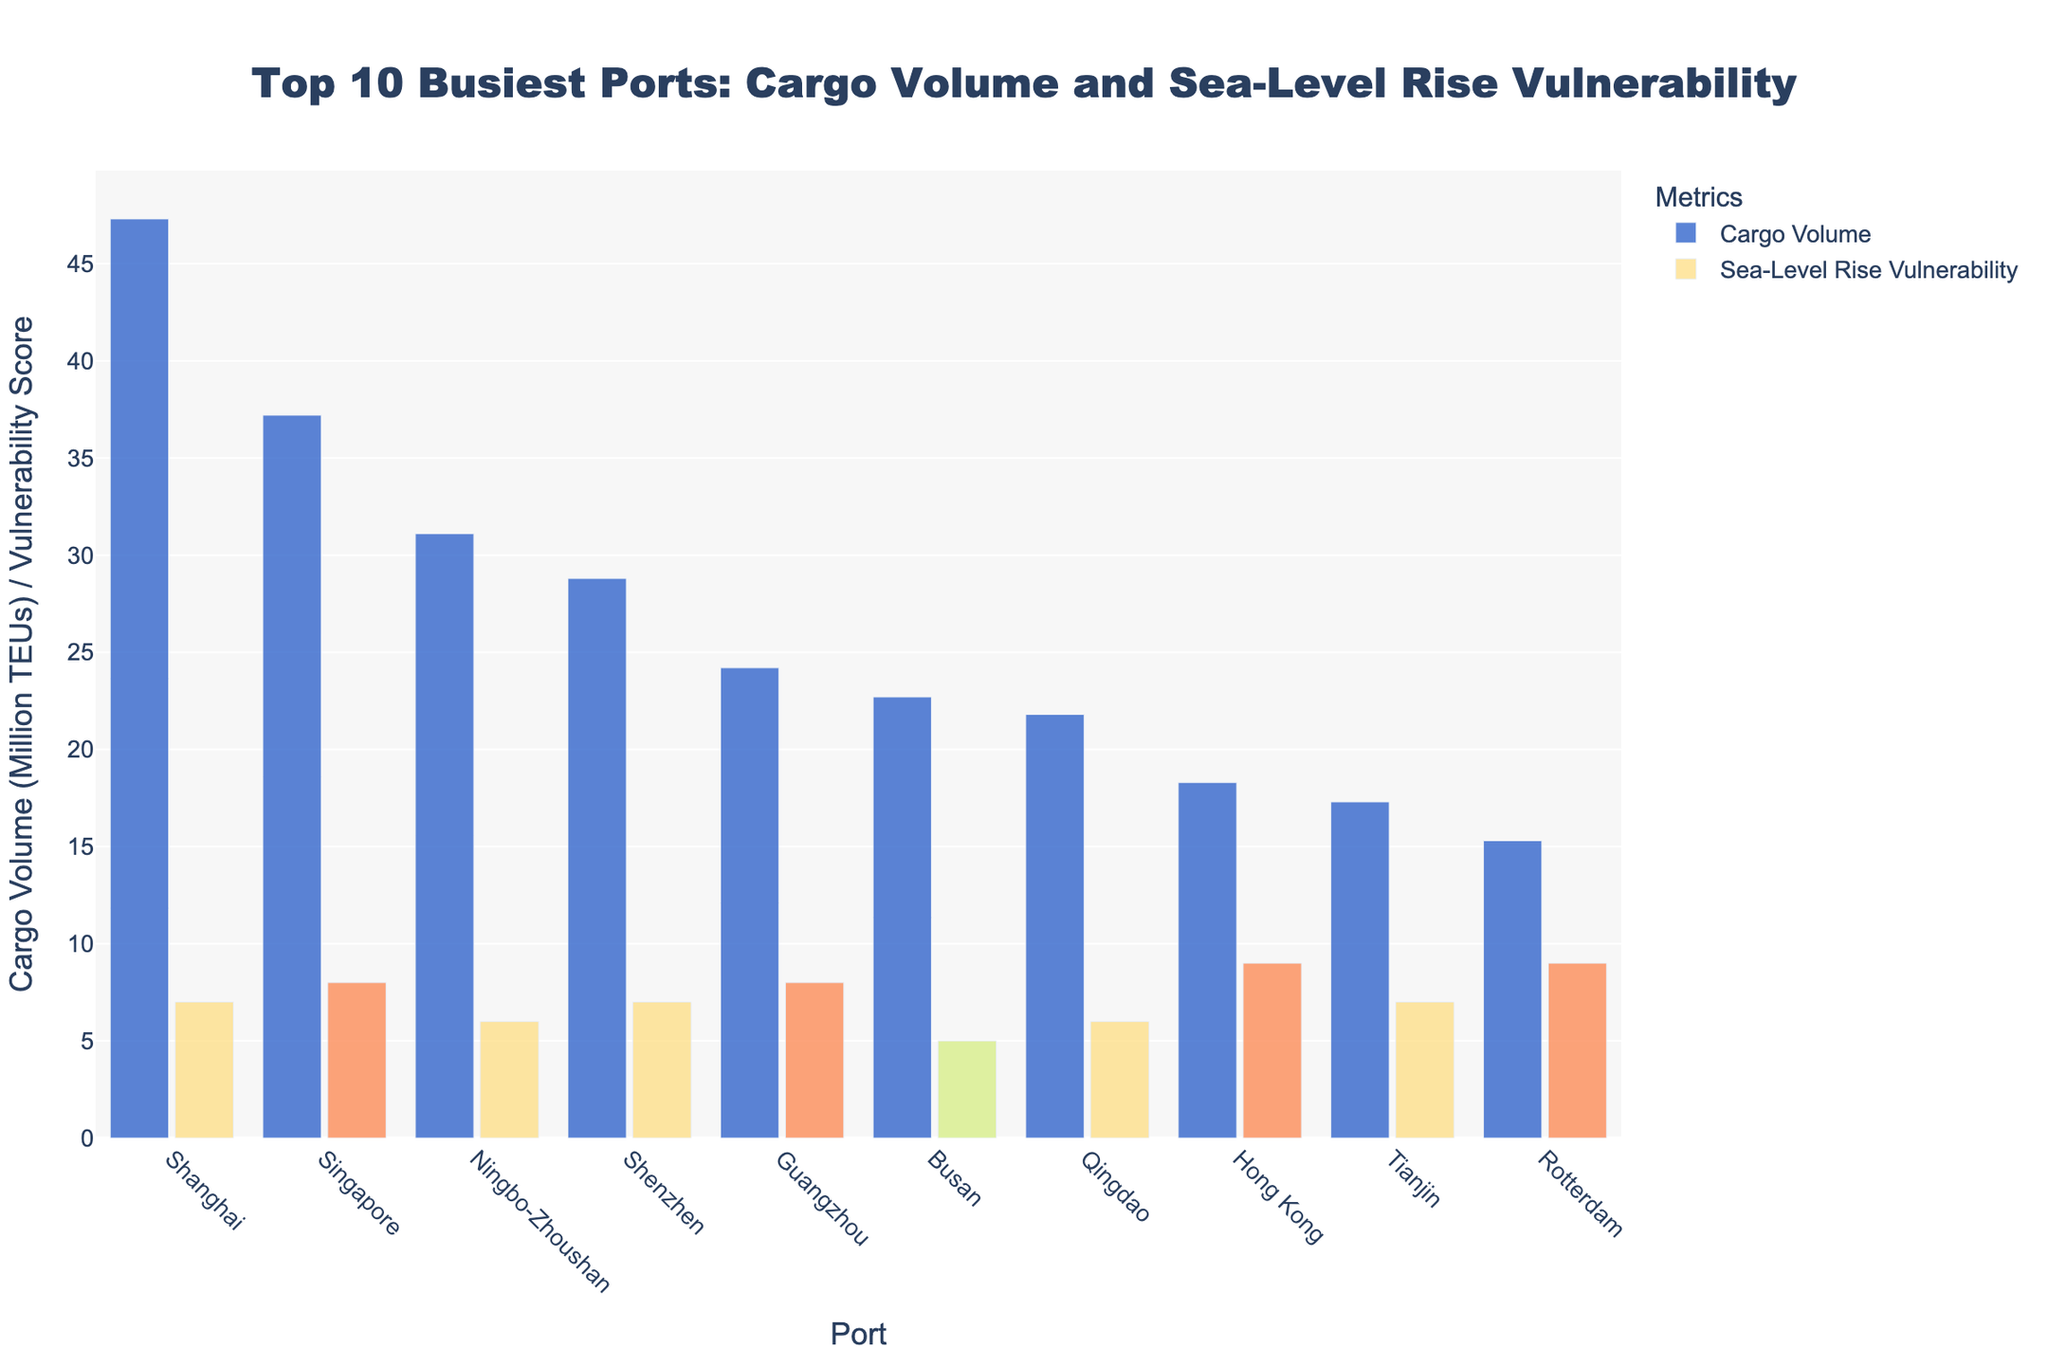Which port has the highest cargo volume? By examining the height of the bars, the port with the highest cargo volume is the one with the tallest bar under "Cargo Volume". Here, Shanghai has the tallest bar.
Answer: Shanghai Which port has the highest sea level rise vulnerability? By looking at the port with the highest bar for "Sea-Level Rise Vulnerability", the highest score is indicated by the tallest bar. Here, both Hong Kong and Rotterdam have the highest vulnerability scores.
Answer: Hong Kong and Rotterdam What's the difference in cargo volume between the port with the highest volume and the port with the lowest volume? First, find the highest cargo volume which is Shanghai with 47.3 Million TEUs. Then find the lowest cargo volume which is Rotterdam with 15.3 Million TEUs. The difference is 47.3 - 15.3.
Answer: 32 Million TEUs Which port has the highest combined score of cargo volume and sea level rise vulnerability? Calculate the sum for each port by adding both the cargo volume and the vulnerability score and find which is the highest. For example, Shanghai: 47.3 + 7 = 54.3, Singapore: 37.2 + 8 = 45.2, etc.
Answer: Shanghai (54.3) How many ports have a sea level rise vulnerability score of 7 or higher? Count the ports with a sea-level rise vulnerability score of 7 or above. Here, they are Shanghai, Singapore, Shenzhen, Guangzhou, Hong Kong, and Tianjin.
Answer: 6 ports Is the sea level rise vulnerability of Busan higher or lower than that of Ningbo-Zhoushan? Compare the heights of the bars for the sea level rise vulnerability of Busan and Ningbo-Zhoushan. Here, Busan has a score of 5 and Ningbo-Zhoushan has a score of 6.
Answer: Lower Which port has almost equal cargo volume and sea level rise vulnerability scores? Compare the heights of the bars within each port and see which pair of bars are nearly the same height. Here, Hong Kong has a cargo volume of 18.3 and a vulnerability of 9.
Answer: Hong Kong What is the average cargo volume for the top 3 busiest ports? To find the average, sum the cargo volumes of the top 3 busiest ports (Shanghai, Singapore, Ningbo-Zhoushan) and divide by 3. (47.3 + 37.2 + 31.1) / 3 = 38.53 Million TEUs.
Answer: 38.53 Million TEUs 